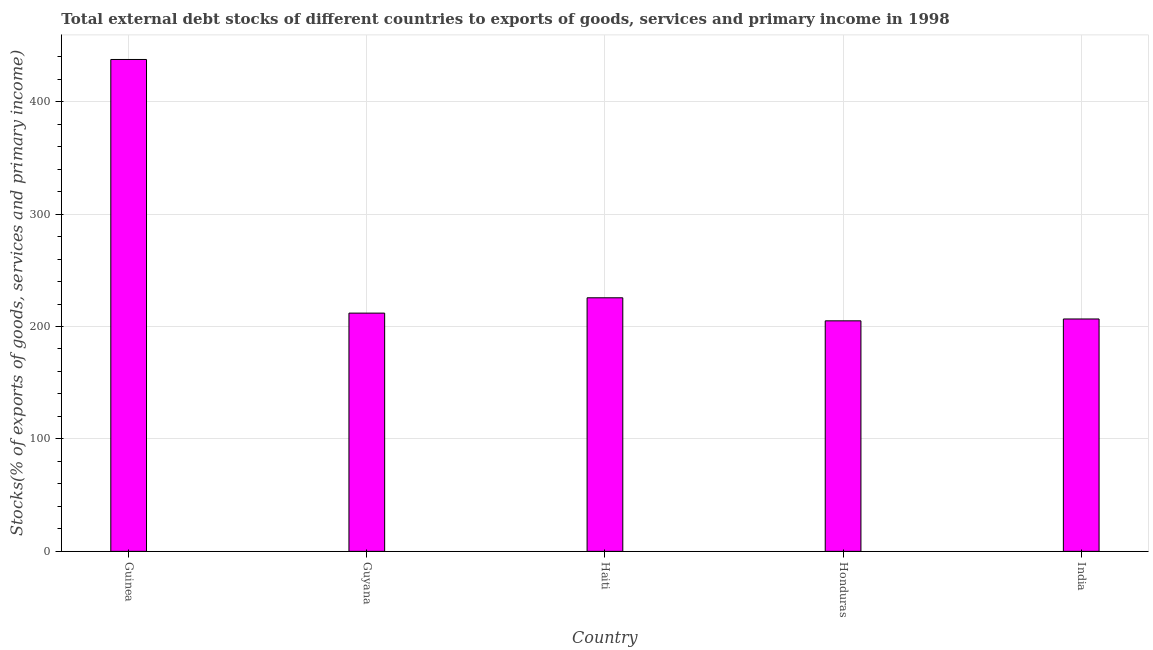Does the graph contain grids?
Your answer should be compact. Yes. What is the title of the graph?
Your response must be concise. Total external debt stocks of different countries to exports of goods, services and primary income in 1998. What is the label or title of the X-axis?
Offer a very short reply. Country. What is the label or title of the Y-axis?
Provide a short and direct response. Stocks(% of exports of goods, services and primary income). What is the external debt stocks in Guyana?
Ensure brevity in your answer.  211.9. Across all countries, what is the maximum external debt stocks?
Provide a short and direct response. 437.52. Across all countries, what is the minimum external debt stocks?
Your answer should be very brief. 205.04. In which country was the external debt stocks maximum?
Provide a short and direct response. Guinea. In which country was the external debt stocks minimum?
Your answer should be very brief. Honduras. What is the sum of the external debt stocks?
Your answer should be very brief. 1286.69. What is the difference between the external debt stocks in Guinea and India?
Your answer should be compact. 230.82. What is the average external debt stocks per country?
Keep it short and to the point. 257.34. What is the median external debt stocks?
Provide a short and direct response. 211.9. What is the ratio of the external debt stocks in Guyana to that in India?
Ensure brevity in your answer.  1.02. Is the external debt stocks in Haiti less than that in Honduras?
Your answer should be compact. No. Is the difference between the external debt stocks in Guyana and Haiti greater than the difference between any two countries?
Make the answer very short. No. What is the difference between the highest and the second highest external debt stocks?
Offer a terse response. 211.98. What is the difference between the highest and the lowest external debt stocks?
Ensure brevity in your answer.  232.48. How many countries are there in the graph?
Make the answer very short. 5. What is the difference between two consecutive major ticks on the Y-axis?
Provide a short and direct response. 100. Are the values on the major ticks of Y-axis written in scientific E-notation?
Your answer should be compact. No. What is the Stocks(% of exports of goods, services and primary income) of Guinea?
Offer a terse response. 437.52. What is the Stocks(% of exports of goods, services and primary income) of Guyana?
Offer a terse response. 211.9. What is the Stocks(% of exports of goods, services and primary income) in Haiti?
Ensure brevity in your answer.  225.54. What is the Stocks(% of exports of goods, services and primary income) of Honduras?
Offer a very short reply. 205.04. What is the Stocks(% of exports of goods, services and primary income) in India?
Your response must be concise. 206.7. What is the difference between the Stocks(% of exports of goods, services and primary income) in Guinea and Guyana?
Make the answer very short. 225.61. What is the difference between the Stocks(% of exports of goods, services and primary income) in Guinea and Haiti?
Your answer should be compact. 211.98. What is the difference between the Stocks(% of exports of goods, services and primary income) in Guinea and Honduras?
Your answer should be compact. 232.48. What is the difference between the Stocks(% of exports of goods, services and primary income) in Guinea and India?
Provide a short and direct response. 230.82. What is the difference between the Stocks(% of exports of goods, services and primary income) in Guyana and Haiti?
Make the answer very short. -13.64. What is the difference between the Stocks(% of exports of goods, services and primary income) in Guyana and Honduras?
Make the answer very short. 6.86. What is the difference between the Stocks(% of exports of goods, services and primary income) in Guyana and India?
Offer a very short reply. 5.2. What is the difference between the Stocks(% of exports of goods, services and primary income) in Haiti and Honduras?
Offer a very short reply. 20.5. What is the difference between the Stocks(% of exports of goods, services and primary income) in Haiti and India?
Offer a very short reply. 18.84. What is the difference between the Stocks(% of exports of goods, services and primary income) in Honduras and India?
Give a very brief answer. -1.66. What is the ratio of the Stocks(% of exports of goods, services and primary income) in Guinea to that in Guyana?
Ensure brevity in your answer.  2.06. What is the ratio of the Stocks(% of exports of goods, services and primary income) in Guinea to that in Haiti?
Provide a short and direct response. 1.94. What is the ratio of the Stocks(% of exports of goods, services and primary income) in Guinea to that in Honduras?
Provide a succinct answer. 2.13. What is the ratio of the Stocks(% of exports of goods, services and primary income) in Guinea to that in India?
Offer a very short reply. 2.12. What is the ratio of the Stocks(% of exports of goods, services and primary income) in Guyana to that in Honduras?
Your answer should be compact. 1.03. What is the ratio of the Stocks(% of exports of goods, services and primary income) in Haiti to that in Honduras?
Your answer should be very brief. 1.1. What is the ratio of the Stocks(% of exports of goods, services and primary income) in Haiti to that in India?
Make the answer very short. 1.09. What is the ratio of the Stocks(% of exports of goods, services and primary income) in Honduras to that in India?
Provide a succinct answer. 0.99. 